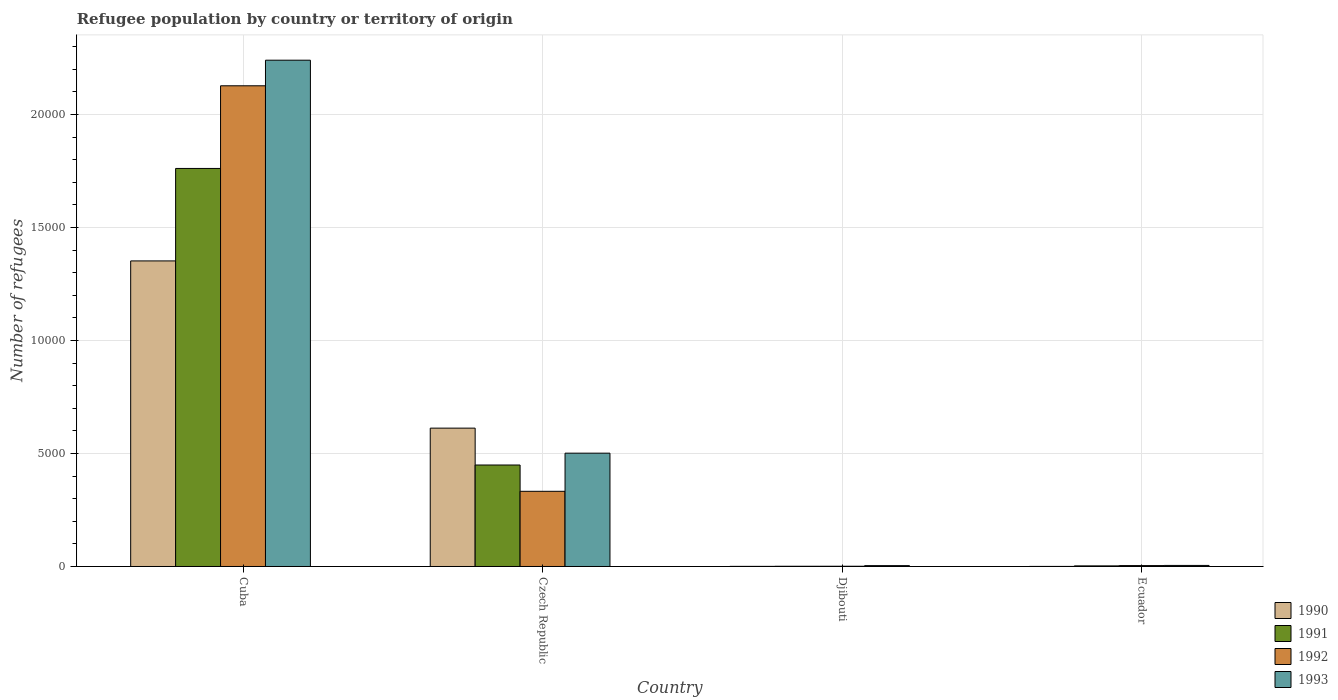How many groups of bars are there?
Offer a very short reply. 4. How many bars are there on the 3rd tick from the left?
Provide a short and direct response. 4. What is the label of the 2nd group of bars from the left?
Offer a very short reply. Czech Republic. In how many cases, is the number of bars for a given country not equal to the number of legend labels?
Keep it short and to the point. 0. Across all countries, what is the maximum number of refugees in 1992?
Your response must be concise. 2.13e+04. In which country was the number of refugees in 1993 maximum?
Offer a very short reply. Cuba. In which country was the number of refugees in 1993 minimum?
Offer a very short reply. Djibouti. What is the total number of refugees in 1991 in the graph?
Offer a terse response. 2.21e+04. What is the difference between the number of refugees in 1991 in Cuba and that in Ecuador?
Provide a succinct answer. 1.76e+04. What is the difference between the number of refugees in 1990 in Djibouti and the number of refugees in 1991 in Ecuador?
Provide a succinct answer. -22. What is the average number of refugees in 1990 per country?
Your answer should be very brief. 4913.5. What is the ratio of the number of refugees in 1992 in Czech Republic to that in Ecuador?
Provide a succinct answer. 83.17. Is the number of refugees in 1993 in Czech Republic less than that in Ecuador?
Provide a succinct answer. No. What is the difference between the highest and the second highest number of refugees in 1990?
Offer a very short reply. 1.35e+04. What is the difference between the highest and the lowest number of refugees in 1993?
Your answer should be very brief. 2.24e+04. In how many countries, is the number of refugees in 1992 greater than the average number of refugees in 1992 taken over all countries?
Ensure brevity in your answer.  1. Is the sum of the number of refugees in 1991 in Djibouti and Ecuador greater than the maximum number of refugees in 1993 across all countries?
Offer a very short reply. No. How many countries are there in the graph?
Make the answer very short. 4. What is the difference between two consecutive major ticks on the Y-axis?
Offer a terse response. 5000. Are the values on the major ticks of Y-axis written in scientific E-notation?
Your answer should be very brief. No. Where does the legend appear in the graph?
Provide a succinct answer. Bottom right. How many legend labels are there?
Ensure brevity in your answer.  4. How are the legend labels stacked?
Offer a very short reply. Vertical. What is the title of the graph?
Your answer should be compact. Refugee population by country or territory of origin. Does "2000" appear as one of the legend labels in the graph?
Keep it short and to the point. No. What is the label or title of the X-axis?
Make the answer very short. Country. What is the label or title of the Y-axis?
Your answer should be compact. Number of refugees. What is the Number of refugees in 1990 in Cuba?
Your answer should be compact. 1.35e+04. What is the Number of refugees in 1991 in Cuba?
Provide a succinct answer. 1.76e+04. What is the Number of refugees of 1992 in Cuba?
Your answer should be compact. 2.13e+04. What is the Number of refugees in 1993 in Cuba?
Make the answer very short. 2.24e+04. What is the Number of refugees in 1990 in Czech Republic?
Keep it short and to the point. 6123. What is the Number of refugees of 1991 in Czech Republic?
Make the answer very short. 4491. What is the Number of refugees of 1992 in Czech Republic?
Offer a very short reply. 3327. What is the Number of refugees of 1993 in Czech Republic?
Provide a succinct answer. 5015. What is the Number of refugees in 1990 in Djibouti?
Give a very brief answer. 5. What is the Number of refugees of 1992 in Djibouti?
Your response must be concise. 11. Across all countries, what is the maximum Number of refugees in 1990?
Your answer should be compact. 1.35e+04. Across all countries, what is the maximum Number of refugees in 1991?
Your response must be concise. 1.76e+04. Across all countries, what is the maximum Number of refugees of 1992?
Offer a very short reply. 2.13e+04. Across all countries, what is the maximum Number of refugees in 1993?
Your response must be concise. 2.24e+04. Across all countries, what is the minimum Number of refugees in 1990?
Offer a very short reply. 3. What is the total Number of refugees in 1990 in the graph?
Keep it short and to the point. 1.97e+04. What is the total Number of refugees of 1991 in the graph?
Your answer should be very brief. 2.21e+04. What is the total Number of refugees of 1992 in the graph?
Provide a succinct answer. 2.47e+04. What is the total Number of refugees of 1993 in the graph?
Your response must be concise. 2.75e+04. What is the difference between the Number of refugees in 1990 in Cuba and that in Czech Republic?
Your answer should be very brief. 7400. What is the difference between the Number of refugees in 1991 in Cuba and that in Czech Republic?
Keep it short and to the point. 1.31e+04. What is the difference between the Number of refugees in 1992 in Cuba and that in Czech Republic?
Offer a terse response. 1.79e+04. What is the difference between the Number of refugees in 1993 in Cuba and that in Czech Republic?
Offer a terse response. 1.74e+04. What is the difference between the Number of refugees in 1990 in Cuba and that in Djibouti?
Offer a terse response. 1.35e+04. What is the difference between the Number of refugees in 1991 in Cuba and that in Djibouti?
Give a very brief answer. 1.76e+04. What is the difference between the Number of refugees in 1992 in Cuba and that in Djibouti?
Provide a succinct answer. 2.13e+04. What is the difference between the Number of refugees in 1993 in Cuba and that in Djibouti?
Your answer should be compact. 2.24e+04. What is the difference between the Number of refugees in 1990 in Cuba and that in Ecuador?
Keep it short and to the point. 1.35e+04. What is the difference between the Number of refugees of 1991 in Cuba and that in Ecuador?
Offer a terse response. 1.76e+04. What is the difference between the Number of refugees of 1992 in Cuba and that in Ecuador?
Make the answer very short. 2.12e+04. What is the difference between the Number of refugees in 1993 in Cuba and that in Ecuador?
Your answer should be very brief. 2.24e+04. What is the difference between the Number of refugees in 1990 in Czech Republic and that in Djibouti?
Offer a terse response. 6118. What is the difference between the Number of refugees of 1991 in Czech Republic and that in Djibouti?
Your answer should be compact. 4481. What is the difference between the Number of refugees in 1992 in Czech Republic and that in Djibouti?
Give a very brief answer. 3316. What is the difference between the Number of refugees of 1993 in Czech Republic and that in Djibouti?
Offer a very short reply. 4977. What is the difference between the Number of refugees of 1990 in Czech Republic and that in Ecuador?
Provide a succinct answer. 6120. What is the difference between the Number of refugees of 1991 in Czech Republic and that in Ecuador?
Provide a succinct answer. 4464. What is the difference between the Number of refugees of 1992 in Czech Republic and that in Ecuador?
Keep it short and to the point. 3287. What is the difference between the Number of refugees of 1993 in Czech Republic and that in Ecuador?
Your response must be concise. 4968. What is the difference between the Number of refugees of 1991 in Djibouti and that in Ecuador?
Provide a short and direct response. -17. What is the difference between the Number of refugees of 1990 in Cuba and the Number of refugees of 1991 in Czech Republic?
Keep it short and to the point. 9032. What is the difference between the Number of refugees in 1990 in Cuba and the Number of refugees in 1992 in Czech Republic?
Keep it short and to the point. 1.02e+04. What is the difference between the Number of refugees in 1990 in Cuba and the Number of refugees in 1993 in Czech Republic?
Offer a very short reply. 8508. What is the difference between the Number of refugees of 1991 in Cuba and the Number of refugees of 1992 in Czech Republic?
Provide a succinct answer. 1.43e+04. What is the difference between the Number of refugees of 1991 in Cuba and the Number of refugees of 1993 in Czech Republic?
Your answer should be compact. 1.26e+04. What is the difference between the Number of refugees of 1992 in Cuba and the Number of refugees of 1993 in Czech Republic?
Provide a short and direct response. 1.63e+04. What is the difference between the Number of refugees in 1990 in Cuba and the Number of refugees in 1991 in Djibouti?
Offer a terse response. 1.35e+04. What is the difference between the Number of refugees in 1990 in Cuba and the Number of refugees in 1992 in Djibouti?
Offer a very short reply. 1.35e+04. What is the difference between the Number of refugees of 1990 in Cuba and the Number of refugees of 1993 in Djibouti?
Ensure brevity in your answer.  1.35e+04. What is the difference between the Number of refugees of 1991 in Cuba and the Number of refugees of 1992 in Djibouti?
Your response must be concise. 1.76e+04. What is the difference between the Number of refugees of 1991 in Cuba and the Number of refugees of 1993 in Djibouti?
Offer a terse response. 1.76e+04. What is the difference between the Number of refugees in 1992 in Cuba and the Number of refugees in 1993 in Djibouti?
Offer a very short reply. 2.12e+04. What is the difference between the Number of refugees of 1990 in Cuba and the Number of refugees of 1991 in Ecuador?
Make the answer very short. 1.35e+04. What is the difference between the Number of refugees of 1990 in Cuba and the Number of refugees of 1992 in Ecuador?
Offer a very short reply. 1.35e+04. What is the difference between the Number of refugees of 1990 in Cuba and the Number of refugees of 1993 in Ecuador?
Your answer should be compact. 1.35e+04. What is the difference between the Number of refugees in 1991 in Cuba and the Number of refugees in 1992 in Ecuador?
Your response must be concise. 1.76e+04. What is the difference between the Number of refugees of 1991 in Cuba and the Number of refugees of 1993 in Ecuador?
Provide a succinct answer. 1.76e+04. What is the difference between the Number of refugees of 1992 in Cuba and the Number of refugees of 1993 in Ecuador?
Your answer should be compact. 2.12e+04. What is the difference between the Number of refugees in 1990 in Czech Republic and the Number of refugees in 1991 in Djibouti?
Provide a short and direct response. 6113. What is the difference between the Number of refugees of 1990 in Czech Republic and the Number of refugees of 1992 in Djibouti?
Your answer should be compact. 6112. What is the difference between the Number of refugees of 1990 in Czech Republic and the Number of refugees of 1993 in Djibouti?
Give a very brief answer. 6085. What is the difference between the Number of refugees of 1991 in Czech Republic and the Number of refugees of 1992 in Djibouti?
Your answer should be very brief. 4480. What is the difference between the Number of refugees in 1991 in Czech Republic and the Number of refugees in 1993 in Djibouti?
Your response must be concise. 4453. What is the difference between the Number of refugees in 1992 in Czech Republic and the Number of refugees in 1993 in Djibouti?
Provide a short and direct response. 3289. What is the difference between the Number of refugees of 1990 in Czech Republic and the Number of refugees of 1991 in Ecuador?
Offer a very short reply. 6096. What is the difference between the Number of refugees in 1990 in Czech Republic and the Number of refugees in 1992 in Ecuador?
Provide a short and direct response. 6083. What is the difference between the Number of refugees of 1990 in Czech Republic and the Number of refugees of 1993 in Ecuador?
Give a very brief answer. 6076. What is the difference between the Number of refugees of 1991 in Czech Republic and the Number of refugees of 1992 in Ecuador?
Provide a succinct answer. 4451. What is the difference between the Number of refugees of 1991 in Czech Republic and the Number of refugees of 1993 in Ecuador?
Provide a succinct answer. 4444. What is the difference between the Number of refugees of 1992 in Czech Republic and the Number of refugees of 1993 in Ecuador?
Offer a terse response. 3280. What is the difference between the Number of refugees of 1990 in Djibouti and the Number of refugees of 1992 in Ecuador?
Your answer should be compact. -35. What is the difference between the Number of refugees in 1990 in Djibouti and the Number of refugees in 1993 in Ecuador?
Provide a succinct answer. -42. What is the difference between the Number of refugees in 1991 in Djibouti and the Number of refugees in 1993 in Ecuador?
Provide a short and direct response. -37. What is the difference between the Number of refugees in 1992 in Djibouti and the Number of refugees in 1993 in Ecuador?
Make the answer very short. -36. What is the average Number of refugees of 1990 per country?
Provide a short and direct response. 4913.5. What is the average Number of refugees in 1991 per country?
Your answer should be very brief. 5535.75. What is the average Number of refugees of 1992 per country?
Ensure brevity in your answer.  6162.75. What is the average Number of refugees in 1993 per country?
Give a very brief answer. 6876.5. What is the difference between the Number of refugees of 1990 and Number of refugees of 1991 in Cuba?
Keep it short and to the point. -4092. What is the difference between the Number of refugees of 1990 and Number of refugees of 1992 in Cuba?
Your answer should be compact. -7750. What is the difference between the Number of refugees of 1990 and Number of refugees of 1993 in Cuba?
Offer a very short reply. -8883. What is the difference between the Number of refugees in 1991 and Number of refugees in 1992 in Cuba?
Make the answer very short. -3658. What is the difference between the Number of refugees of 1991 and Number of refugees of 1993 in Cuba?
Your answer should be very brief. -4791. What is the difference between the Number of refugees of 1992 and Number of refugees of 1993 in Cuba?
Your answer should be compact. -1133. What is the difference between the Number of refugees of 1990 and Number of refugees of 1991 in Czech Republic?
Offer a terse response. 1632. What is the difference between the Number of refugees in 1990 and Number of refugees in 1992 in Czech Republic?
Provide a succinct answer. 2796. What is the difference between the Number of refugees of 1990 and Number of refugees of 1993 in Czech Republic?
Give a very brief answer. 1108. What is the difference between the Number of refugees in 1991 and Number of refugees in 1992 in Czech Republic?
Offer a very short reply. 1164. What is the difference between the Number of refugees in 1991 and Number of refugees in 1993 in Czech Republic?
Provide a succinct answer. -524. What is the difference between the Number of refugees in 1992 and Number of refugees in 1993 in Czech Republic?
Your answer should be very brief. -1688. What is the difference between the Number of refugees in 1990 and Number of refugees in 1993 in Djibouti?
Provide a succinct answer. -33. What is the difference between the Number of refugees in 1992 and Number of refugees in 1993 in Djibouti?
Offer a terse response. -27. What is the difference between the Number of refugees of 1990 and Number of refugees of 1992 in Ecuador?
Provide a short and direct response. -37. What is the difference between the Number of refugees of 1990 and Number of refugees of 1993 in Ecuador?
Make the answer very short. -44. What is the difference between the Number of refugees of 1991 and Number of refugees of 1993 in Ecuador?
Offer a very short reply. -20. What is the difference between the Number of refugees of 1992 and Number of refugees of 1993 in Ecuador?
Offer a terse response. -7. What is the ratio of the Number of refugees of 1990 in Cuba to that in Czech Republic?
Offer a terse response. 2.21. What is the ratio of the Number of refugees of 1991 in Cuba to that in Czech Republic?
Keep it short and to the point. 3.92. What is the ratio of the Number of refugees in 1992 in Cuba to that in Czech Republic?
Keep it short and to the point. 6.39. What is the ratio of the Number of refugees in 1993 in Cuba to that in Czech Republic?
Your answer should be compact. 4.47. What is the ratio of the Number of refugees of 1990 in Cuba to that in Djibouti?
Your response must be concise. 2704.6. What is the ratio of the Number of refugees in 1991 in Cuba to that in Djibouti?
Provide a short and direct response. 1761.5. What is the ratio of the Number of refugees in 1992 in Cuba to that in Djibouti?
Give a very brief answer. 1933.91. What is the ratio of the Number of refugees in 1993 in Cuba to that in Djibouti?
Provide a succinct answer. 589.63. What is the ratio of the Number of refugees in 1990 in Cuba to that in Ecuador?
Ensure brevity in your answer.  4507.67. What is the ratio of the Number of refugees in 1991 in Cuba to that in Ecuador?
Provide a short and direct response. 652.41. What is the ratio of the Number of refugees of 1992 in Cuba to that in Ecuador?
Your answer should be very brief. 531.83. What is the ratio of the Number of refugees of 1993 in Cuba to that in Ecuador?
Your response must be concise. 476.72. What is the ratio of the Number of refugees in 1990 in Czech Republic to that in Djibouti?
Keep it short and to the point. 1224.6. What is the ratio of the Number of refugees of 1991 in Czech Republic to that in Djibouti?
Ensure brevity in your answer.  449.1. What is the ratio of the Number of refugees of 1992 in Czech Republic to that in Djibouti?
Keep it short and to the point. 302.45. What is the ratio of the Number of refugees of 1993 in Czech Republic to that in Djibouti?
Offer a very short reply. 131.97. What is the ratio of the Number of refugees of 1990 in Czech Republic to that in Ecuador?
Provide a succinct answer. 2041. What is the ratio of the Number of refugees in 1991 in Czech Republic to that in Ecuador?
Your answer should be compact. 166.33. What is the ratio of the Number of refugees of 1992 in Czech Republic to that in Ecuador?
Offer a terse response. 83.17. What is the ratio of the Number of refugees in 1993 in Czech Republic to that in Ecuador?
Ensure brevity in your answer.  106.7. What is the ratio of the Number of refugees in 1991 in Djibouti to that in Ecuador?
Keep it short and to the point. 0.37. What is the ratio of the Number of refugees of 1992 in Djibouti to that in Ecuador?
Provide a short and direct response. 0.28. What is the ratio of the Number of refugees in 1993 in Djibouti to that in Ecuador?
Give a very brief answer. 0.81. What is the difference between the highest and the second highest Number of refugees of 1990?
Your response must be concise. 7400. What is the difference between the highest and the second highest Number of refugees of 1991?
Keep it short and to the point. 1.31e+04. What is the difference between the highest and the second highest Number of refugees in 1992?
Keep it short and to the point. 1.79e+04. What is the difference between the highest and the second highest Number of refugees of 1993?
Give a very brief answer. 1.74e+04. What is the difference between the highest and the lowest Number of refugees of 1990?
Your answer should be very brief. 1.35e+04. What is the difference between the highest and the lowest Number of refugees in 1991?
Your response must be concise. 1.76e+04. What is the difference between the highest and the lowest Number of refugees of 1992?
Your answer should be compact. 2.13e+04. What is the difference between the highest and the lowest Number of refugees in 1993?
Make the answer very short. 2.24e+04. 